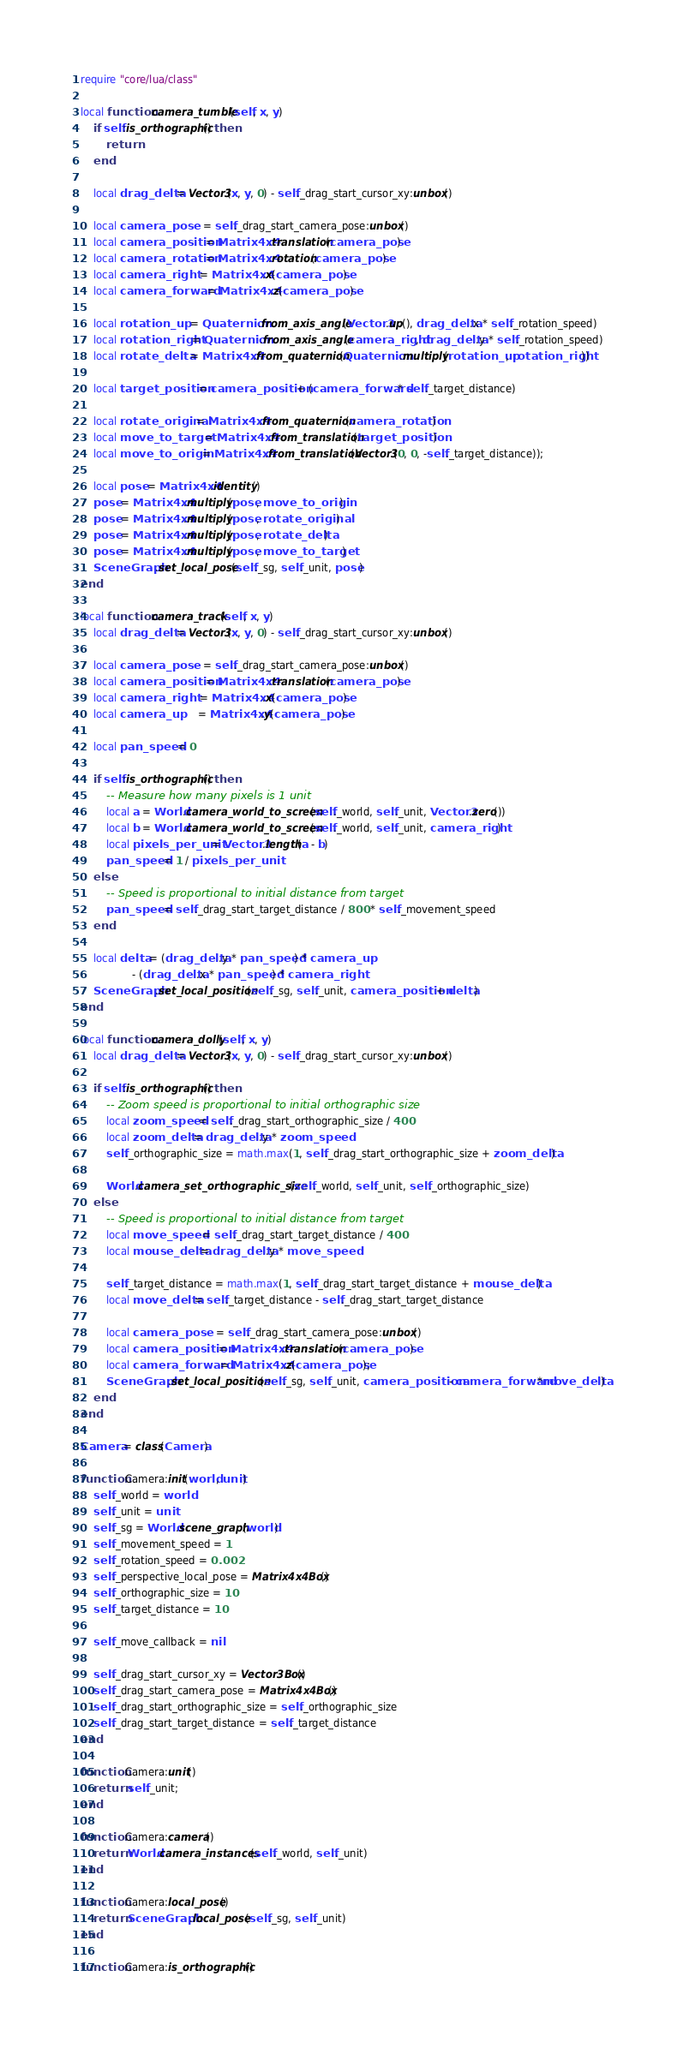Convert code to text. <code><loc_0><loc_0><loc_500><loc_500><_Lua_>require "core/lua/class"

local function camera_tumble(self, x, y)
	if self:is_orthographic() then
		return
	end

	local drag_delta = Vector3(x, y, 0) - self._drag_start_cursor_xy:unbox()

	local camera_pose     = self._drag_start_camera_pose:unbox()
	local camera_position = Matrix4x4.translation(camera_pose)
	local camera_rotation = Matrix4x4.rotation(camera_pose)
	local camera_right    = Matrix4x4.x(camera_pose)
	local camera_forward  = Matrix4x4.z(camera_pose)

	local rotation_up    = Quaternion.from_axis_angle(Vector3.up(), drag_delta.x * self._rotation_speed)
	local rotation_right = Quaternion.from_axis_angle(camera_right, drag_delta.y * self._rotation_speed)
	local rotate_delta   = Matrix4x4.from_quaternion(Quaternion.multiply(rotation_up, rotation_right))

	local target_position = camera_position + (camera_forward * self._target_distance)

	local rotate_original = Matrix4x4.from_quaternion(camera_rotation)
	local move_to_target  = Matrix4x4.from_translation(target_position)
	local move_to_origin  = Matrix4x4.from_translation(Vector3(0, 0, -self._target_distance));

	local pose = Matrix4x4.identity()
	pose = Matrix4x4.multiply(pose, move_to_origin)
	pose = Matrix4x4.multiply(pose, rotate_original)
	pose = Matrix4x4.multiply(pose, rotate_delta)
	pose = Matrix4x4.multiply(pose, move_to_target)
	SceneGraph.set_local_pose(self._sg, self._unit, pose)
end

local function camera_track(self, x, y)
	local drag_delta = Vector3(x, y, 0) - self._drag_start_cursor_xy:unbox()

	local camera_pose     = self._drag_start_camera_pose:unbox()
	local camera_position = Matrix4x4.translation(camera_pose)
	local camera_right    = Matrix4x4.x(camera_pose)
	local camera_up       = Matrix4x4.y(camera_pose)

	local pan_speed = 0

	if self:is_orthographic() then
		-- Measure how many pixels is 1 unit
		local a = World.camera_world_to_screen(self._world, self._unit, Vector3.zero())
		local b = World.camera_world_to_screen(self._world, self._unit, camera_right)
		local pixels_per_unit = Vector3.length(a - b)
		pan_speed = 1 / pixels_per_unit
	else
		-- Speed is proportional to initial distance from target
		pan_speed = self._drag_start_target_distance / 800 * self._movement_speed
	end

	local delta = (drag_delta.y * pan_speed) * camera_up
				- (drag_delta.x * pan_speed) * camera_right
	SceneGraph.set_local_position(self._sg, self._unit, camera_position + delta)
end

local function camera_dolly(self, x, y)
	local drag_delta = Vector3(x, y, 0) - self._drag_start_cursor_xy:unbox()

	if self:is_orthographic() then
		-- Zoom speed is proportional to initial orthographic size
		local zoom_speed = self._drag_start_orthographic_size / 400
		local zoom_delta = drag_delta.y * zoom_speed
		self._orthographic_size = math.max(1, self._drag_start_orthographic_size + zoom_delta)

		World.camera_set_orthographic_size(self._world, self._unit, self._orthographic_size)
	else
		-- Speed is proportional to initial distance from target
		local move_speed  = self._drag_start_target_distance / 400
		local mouse_delta = drag_delta.y * move_speed

		self._target_distance = math.max(1, self._drag_start_target_distance + mouse_delta)
		local move_delta = self._target_distance - self._drag_start_target_distance

		local camera_pose     = self._drag_start_camera_pose:unbox()
		local camera_position = Matrix4x4.translation(camera_pose)
		local camera_forward  = Matrix4x4.z(camera_pose);
		SceneGraph.set_local_position(self._sg, self._unit, camera_position - camera_forward*move_delta)
	end
end

Camera = class(Camera)

function Camera:init(world, unit)
	self._world = world
	self._unit = unit
	self._sg = World.scene_graph(world)
	self._movement_speed = 1
	self._rotation_speed = 0.002
	self._perspective_local_pose = Matrix4x4Box()
	self._orthographic_size = 10
	self._target_distance = 10

	self._move_callback = nil

	self._drag_start_cursor_xy = Vector3Box()
	self._drag_start_camera_pose = Matrix4x4Box()
	self._drag_start_orthographic_size = self._orthographic_size
	self._drag_start_target_distance = self._target_distance
end

function Camera:unit()
	return self._unit;
end

function Camera:camera()
	return World.camera_instances(self._world, self._unit)
end

function Camera:local_pose()
	return SceneGraph.local_pose(self._sg, self._unit)
end

function Camera:is_orthographic()</code> 